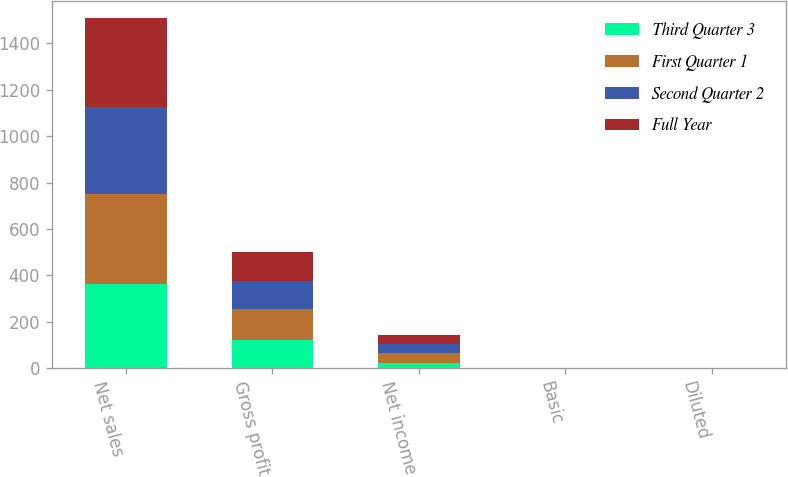Convert chart. <chart><loc_0><loc_0><loc_500><loc_500><stacked_bar_chart><ecel><fcel>Net sales<fcel>Gross profit<fcel>Net income<fcel>Basic<fcel>Diluted<nl><fcel>Third Quarter 3<fcel>362.1<fcel>123.3<fcel>22.1<fcel>0.31<fcel>0.3<nl><fcel>First Quarter 1<fcel>388<fcel>133.3<fcel>44.7<fcel>0.61<fcel>0.6<nl><fcel>Second Quarter 2<fcel>376.7<fcel>121.1<fcel>37.6<fcel>0.51<fcel>0.5<nl><fcel>Full Year<fcel>382.3<fcel>123.4<fcel>39.1<fcel>0.53<fcel>0.52<nl></chart> 